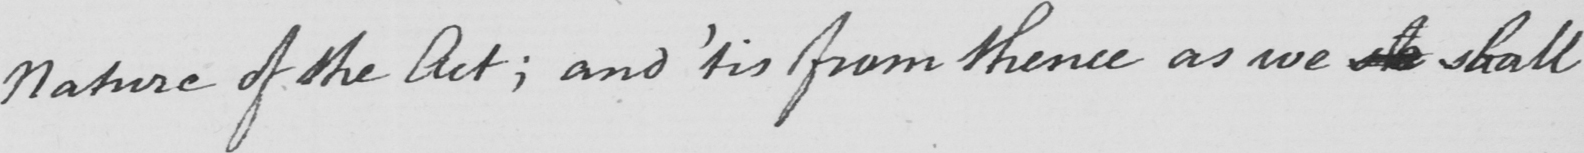What is written in this line of handwriting? Nature of the Act ; and  ' tis from thence as we  <gap/>  shall 